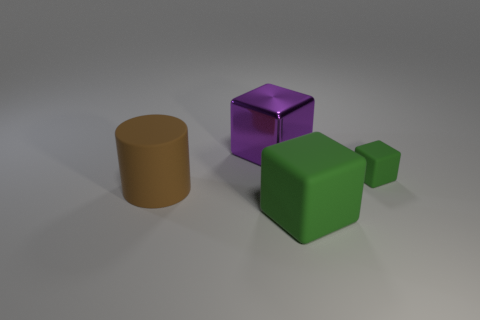What is the shape of the rubber thing that is behind the large green matte block and on the left side of the small thing?
Make the answer very short. Cylinder. What is the tiny cube made of?
Keep it short and to the point. Rubber. What number of cylinders are matte objects or large shiny objects?
Your answer should be compact. 1. Is the big purple block made of the same material as the brown cylinder?
Provide a succinct answer. No. What size is the other rubber object that is the same shape as the big green thing?
Give a very brief answer. Small. What material is the thing that is right of the metallic cube and behind the large brown cylinder?
Keep it short and to the point. Rubber. Are there the same number of purple things left of the big cylinder and big green things?
Provide a short and direct response. No. How many objects are objects that are on the left side of the big purple metal object or small yellow metallic balls?
Make the answer very short. 1. There is a rubber object left of the metallic thing; is its color the same as the large matte block?
Your answer should be compact. No. What is the size of the purple metal object that is behind the brown object?
Keep it short and to the point. Large. 